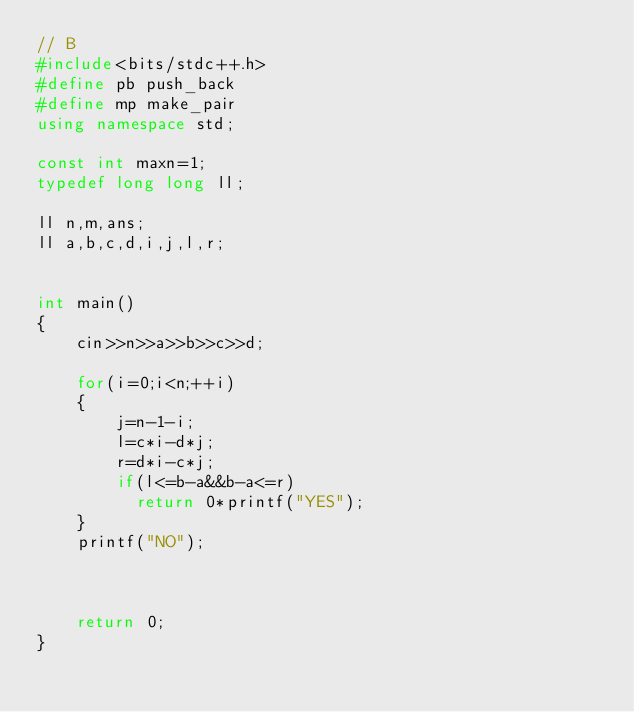<code> <loc_0><loc_0><loc_500><loc_500><_C++_>// B
#include<bits/stdc++.h>
#define pb push_back 
#define mp make_pair
using namespace std;

const int maxn=1;
typedef long long ll;

ll n,m,ans;
ll a,b,c,d,i,j,l,r;


int main()
{
	cin>>n>>a>>b>>c>>d;
	
	for(i=0;i<n;++i)
	{
		j=n-1-i;
		l=c*i-d*j;
		r=d*i-c*j;
		if(l<=b-a&&b-a<=r)
		  return 0*printf("YES");
	}
	printf("NO");
	
	
	
	return 0;
}
</code> 